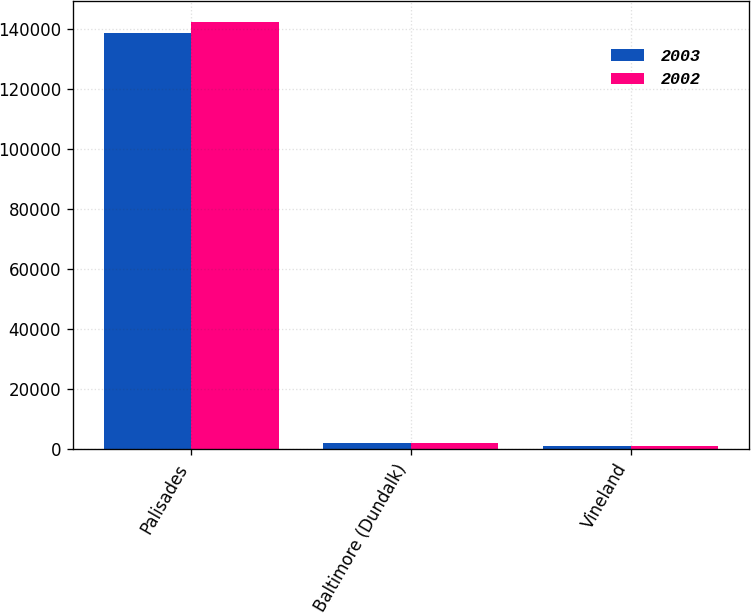Convert chart to OTSL. <chart><loc_0><loc_0><loc_500><loc_500><stacked_bar_chart><ecel><fcel>Palisades<fcel>Baltimore (Dundalk)<fcel>Vineland<nl><fcel>2003<fcel>138629<fcel>2167<fcel>908<nl><fcel>2002<fcel>142333<fcel>2050<fcel>978<nl></chart> 